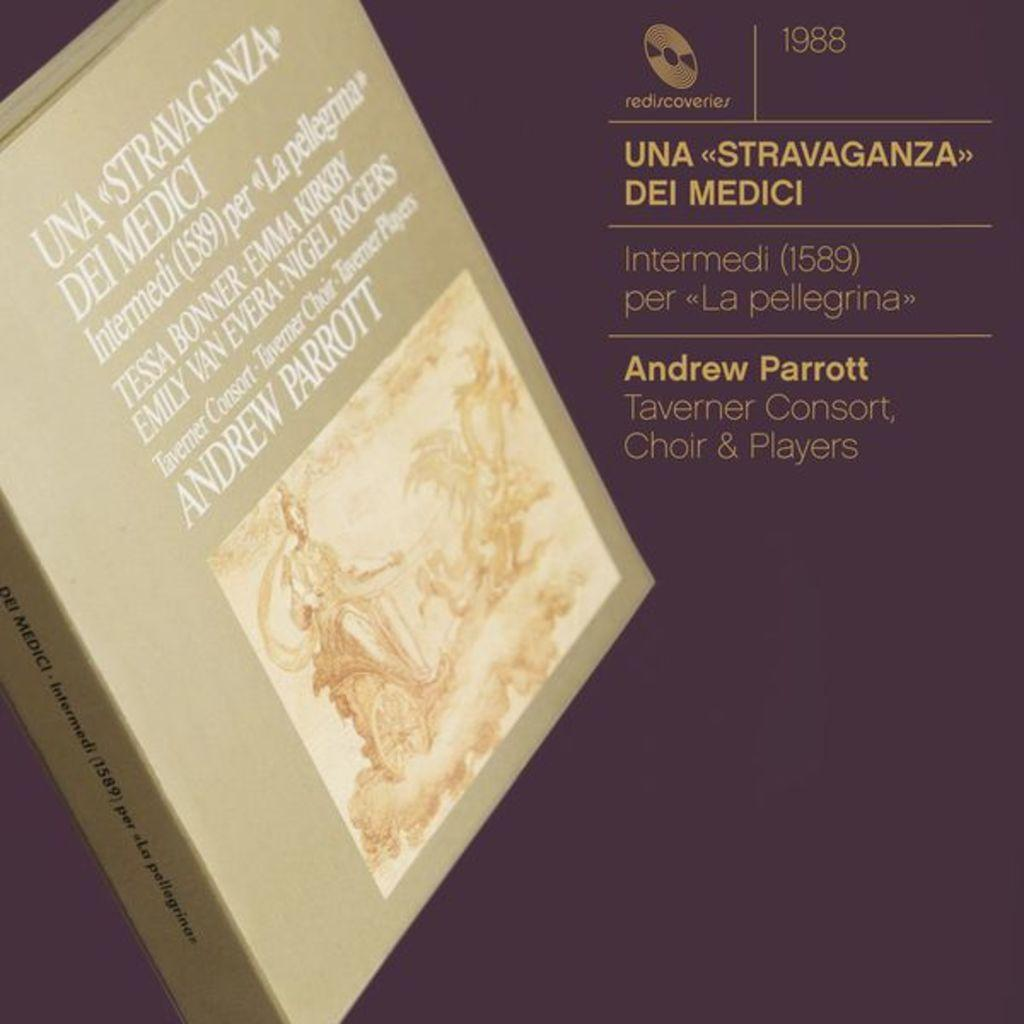Provide a one-sentence caption for the provided image. A 1988 recording by Andrew Parrott and the Taverner consort, choir and players.i. 